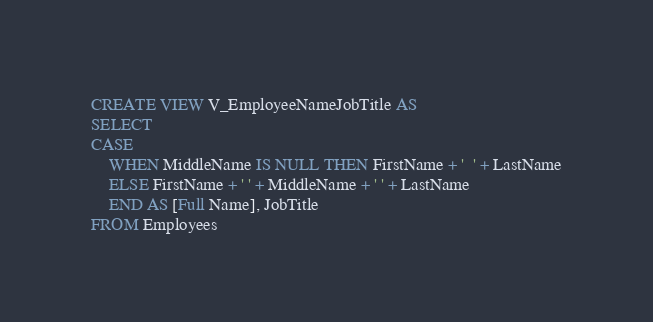Convert code to text. <code><loc_0><loc_0><loc_500><loc_500><_SQL_>CREATE VIEW V_EmployeeNameJobTitle AS
SELECT
CASE
	WHEN MiddleName IS NULL THEN FirstName + '  ' + LastName
	ELSE FirstName + ' ' + MiddleName + ' ' + LastName
	END AS [Full Name], JobTitle
FROM Employees</code> 